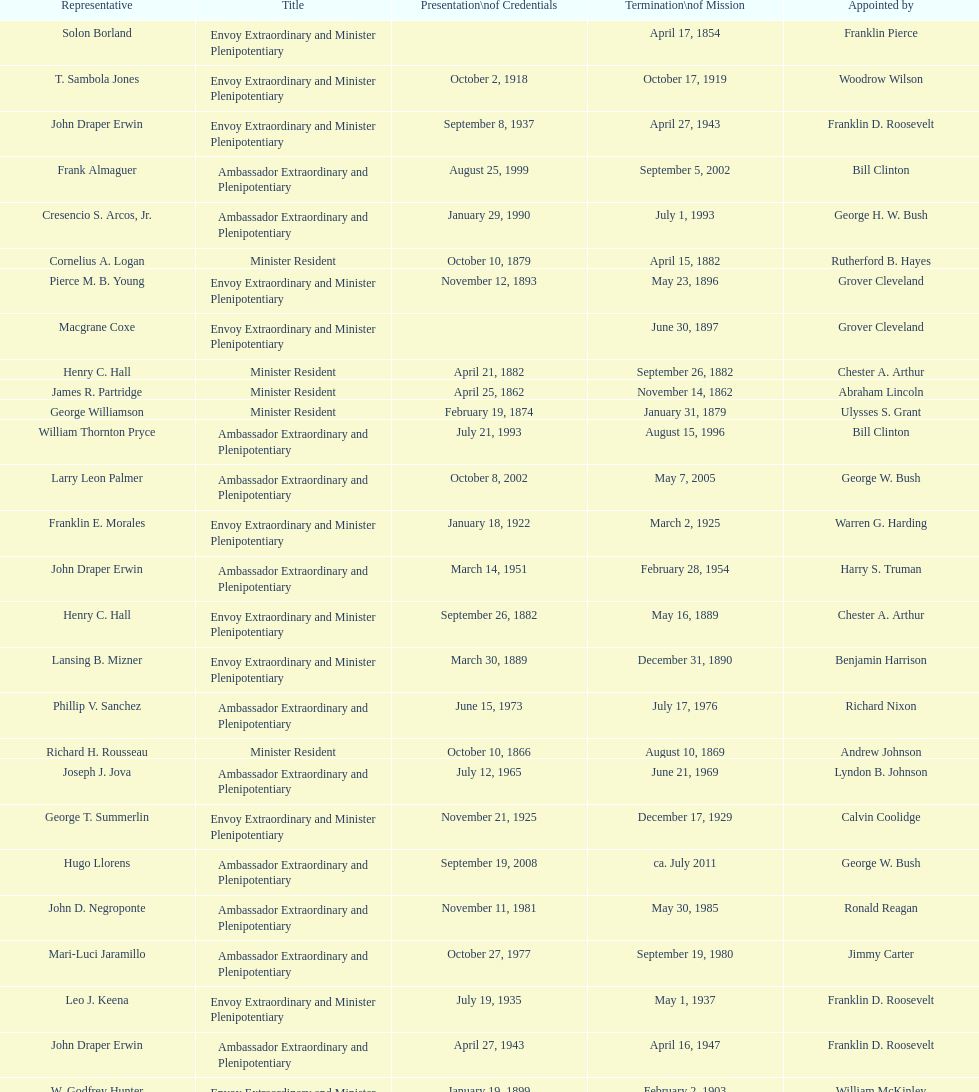How many total representatives have there been? 50. 